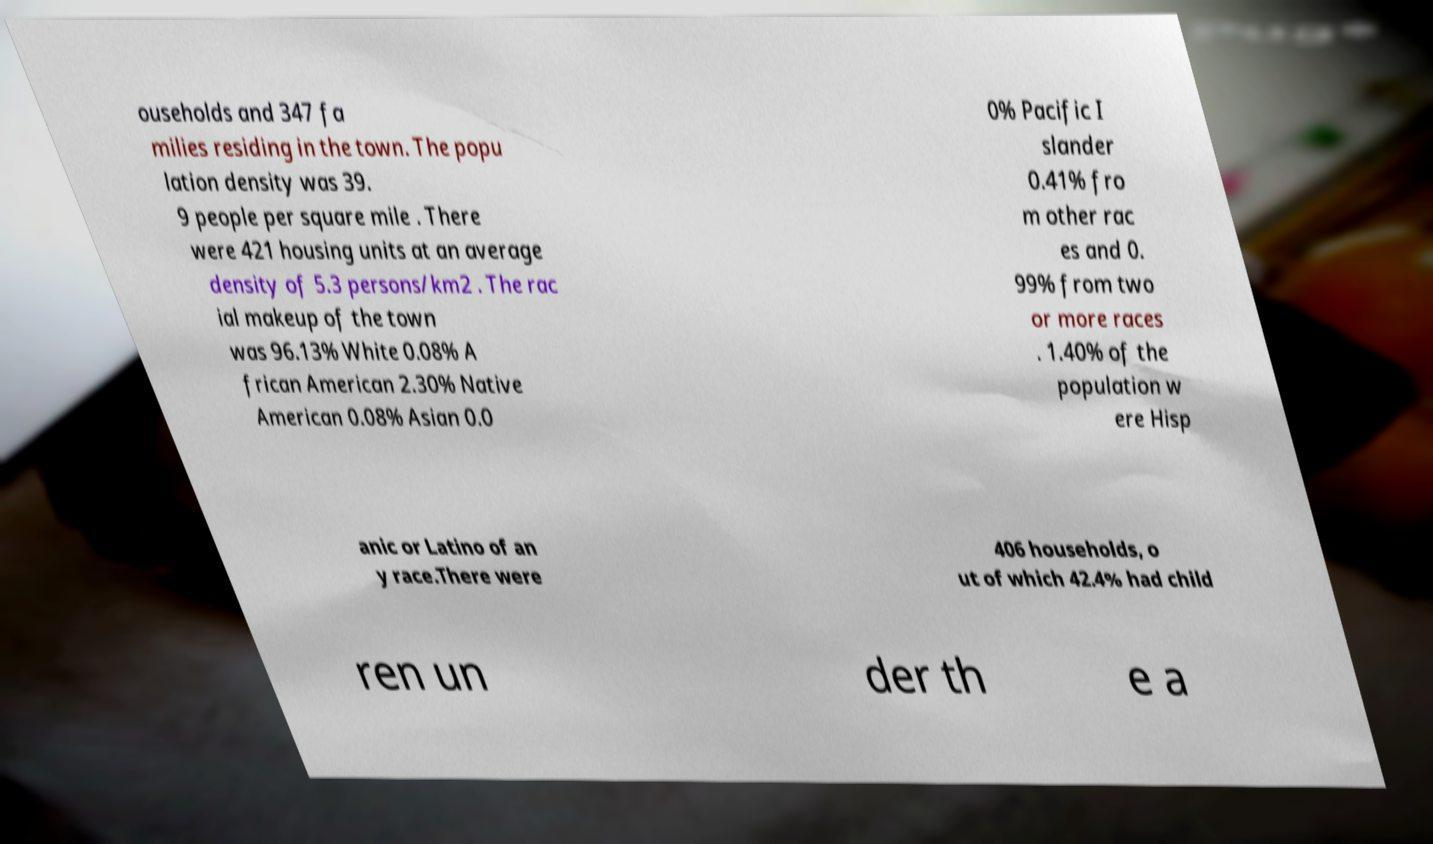What messages or text are displayed in this image? I need them in a readable, typed format. ouseholds and 347 fa milies residing in the town. The popu lation density was 39. 9 people per square mile . There were 421 housing units at an average density of 5.3 persons/km2 . The rac ial makeup of the town was 96.13% White 0.08% A frican American 2.30% Native American 0.08% Asian 0.0 0% Pacific I slander 0.41% fro m other rac es and 0. 99% from two or more races . 1.40% of the population w ere Hisp anic or Latino of an y race.There were 406 households, o ut of which 42.4% had child ren un der th e a 